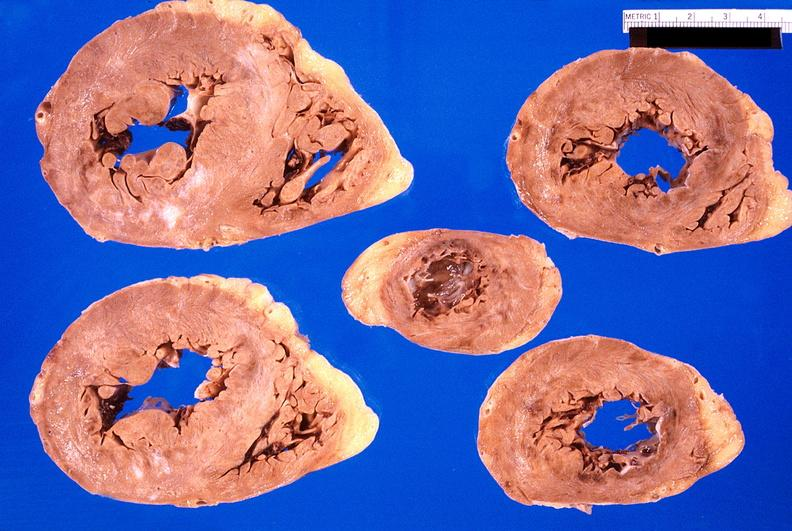where is this?
Answer the question using a single word or phrase. Heart 